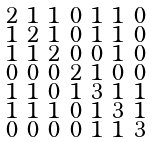Convert formula to latex. <formula><loc_0><loc_0><loc_500><loc_500>\begin{smallmatrix} 2 & 1 & 1 & 0 & 1 & 1 & 0 \\ 1 & 2 & 1 & 0 & 1 & 1 & 0 \\ 1 & 1 & 2 & 0 & 0 & 1 & 0 \\ 0 & 0 & 0 & 2 & 1 & 0 & 0 \\ 1 & 1 & 0 & 1 & 3 & 1 & 1 \\ 1 & 1 & 1 & 0 & 1 & 3 & 1 \\ 0 & 0 & 0 & 0 & 1 & 1 & 3 \end{smallmatrix}</formula> 